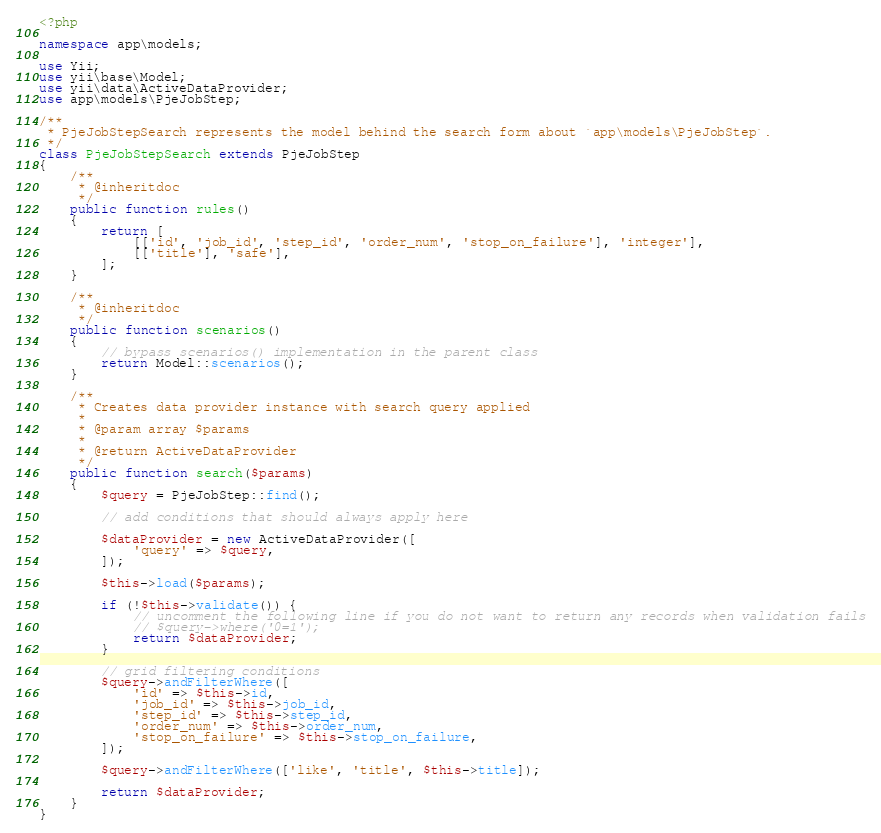Convert code to text. <code><loc_0><loc_0><loc_500><loc_500><_PHP_><?php

namespace app\models;

use Yii;
use yii\base\Model;
use yii\data\ActiveDataProvider;
use app\models\PjeJobStep;

/**
 * PjeJobStepSearch represents the model behind the search form about `app\models\PjeJobStep`.
 */
class PjeJobStepSearch extends PjeJobStep
{
    /**
     * @inheritdoc
     */
    public function rules()
    {
        return [
            [['id', 'job_id', 'step_id', 'order_num', 'stop_on_failure'], 'integer'],
            [['title'], 'safe'],
        ];
    }

    /**
     * @inheritdoc
     */
    public function scenarios()
    {
        // bypass scenarios() implementation in the parent class
        return Model::scenarios();
    }

    /**
     * Creates data provider instance with search query applied
     *
     * @param array $params
     *
     * @return ActiveDataProvider
     */
    public function search($params)
    {
        $query = PjeJobStep::find();

        // add conditions that should always apply here

        $dataProvider = new ActiveDataProvider([
            'query' => $query,
        ]);

        $this->load($params);

        if (!$this->validate()) {
            // uncomment the following line if you do not want to return any records when validation fails
            // $query->where('0=1');
            return $dataProvider;
        }

        // grid filtering conditions
        $query->andFilterWhere([
            'id' => $this->id,
            'job_id' => $this->job_id,
            'step_id' => $this->step_id,
            'order_num' => $this->order_num,
            'stop_on_failure' => $this->stop_on_failure,
        ]);

        $query->andFilterWhere(['like', 'title', $this->title]);

        return $dataProvider;
    }
}
</code> 